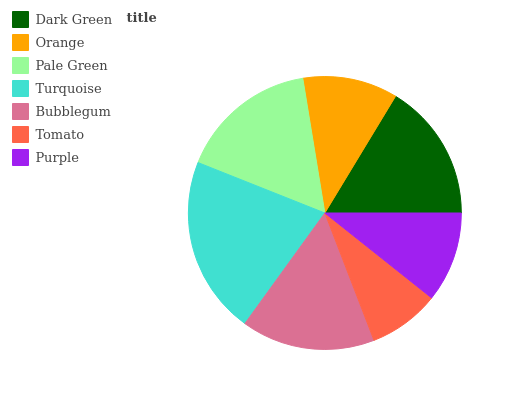Is Tomato the minimum?
Answer yes or no. Yes. Is Turquoise the maximum?
Answer yes or no. Yes. Is Orange the minimum?
Answer yes or no. No. Is Orange the maximum?
Answer yes or no. No. Is Dark Green greater than Orange?
Answer yes or no. Yes. Is Orange less than Dark Green?
Answer yes or no. Yes. Is Orange greater than Dark Green?
Answer yes or no. No. Is Dark Green less than Orange?
Answer yes or no. No. Is Bubblegum the high median?
Answer yes or no. Yes. Is Bubblegum the low median?
Answer yes or no. Yes. Is Turquoise the high median?
Answer yes or no. No. Is Dark Green the low median?
Answer yes or no. No. 